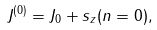Convert formula to latex. <formula><loc_0><loc_0><loc_500><loc_500>J ^ { ( 0 ) } = J _ { 0 } + s _ { z } ( n = 0 ) ,</formula> 